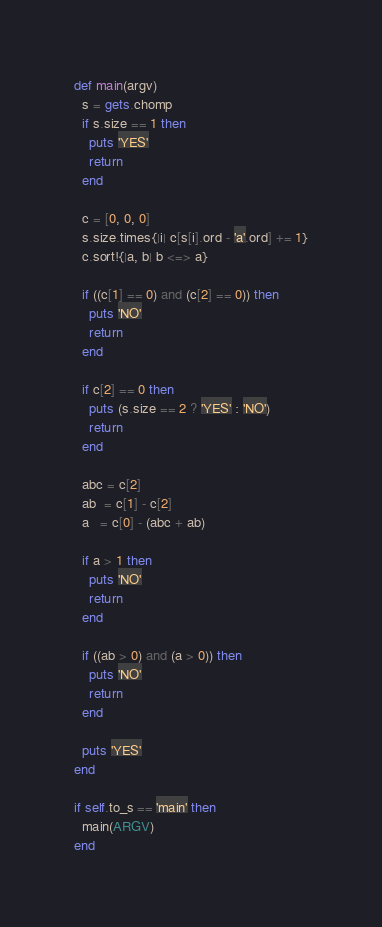Convert code to text. <code><loc_0><loc_0><loc_500><loc_500><_Ruby_>def main(argv)
  s = gets.chomp
  if s.size == 1 then
    puts 'YES'
    return
  end

  c = [0, 0, 0]
  s.size.times{|i| c[s[i].ord - 'a'.ord] += 1}
  c.sort!{|a, b| b <=> a}

  if ((c[1] == 0) and (c[2] == 0)) then
    puts 'NO'
    return
  end

  if c[2] == 0 then
    puts (s.size == 2 ? 'YES' : 'NO')
    return
  end

  abc = c[2]
  ab  = c[1] - c[2]
  a   = c[0] - (abc + ab)

  if a > 1 then
    puts 'NO'
    return
  end

  if ((ab > 0) and (a > 0)) then
    puts 'NO'
    return
  end

  puts 'YES'
end

if self.to_s == 'main' then
  main(ARGV)
end</code> 